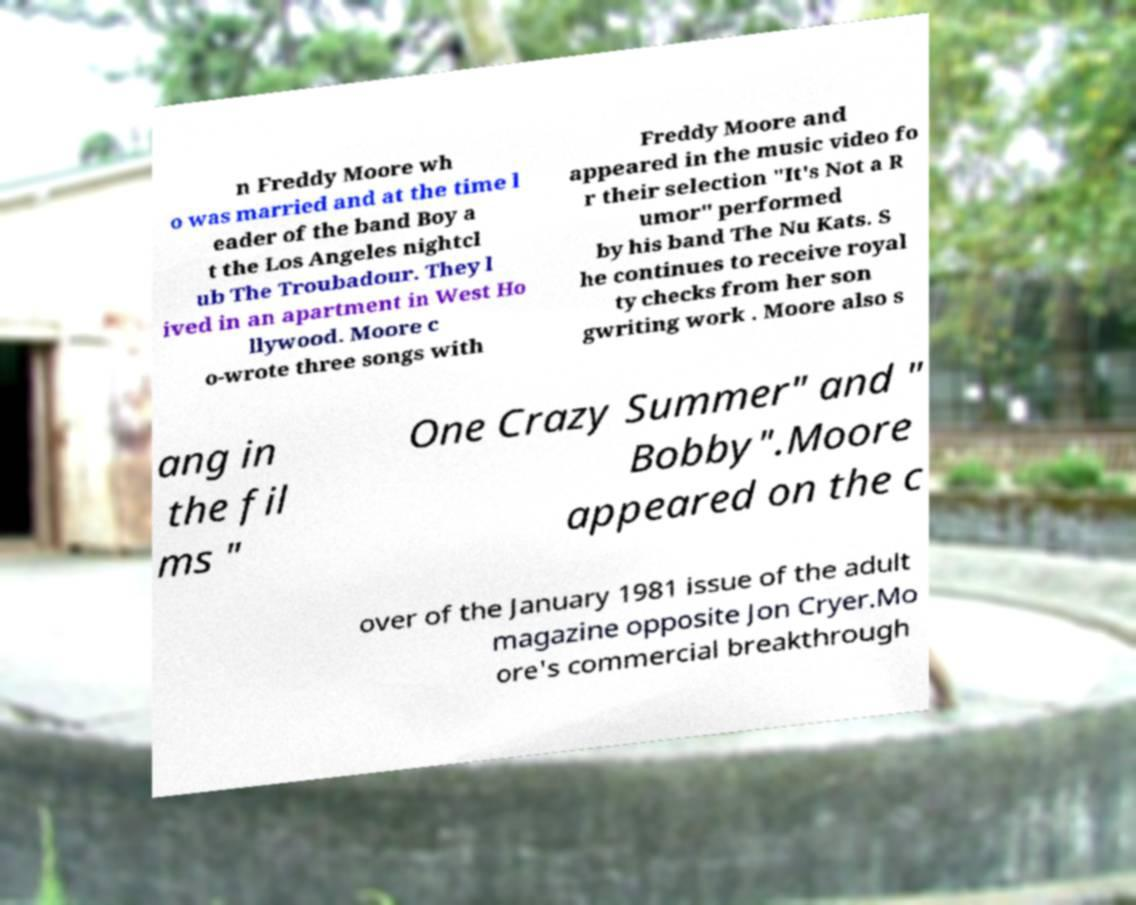Could you extract and type out the text from this image? n Freddy Moore wh o was married and at the time l eader of the band Boy a t the Los Angeles nightcl ub The Troubadour. They l ived in an apartment in West Ho llywood. Moore c o-wrote three songs with Freddy Moore and appeared in the music video fo r their selection "It's Not a R umor" performed by his band The Nu Kats. S he continues to receive royal ty checks from her son gwriting work . Moore also s ang in the fil ms " One Crazy Summer" and " Bobby".Moore appeared on the c over of the January 1981 issue of the adult magazine opposite Jon Cryer.Mo ore's commercial breakthrough 